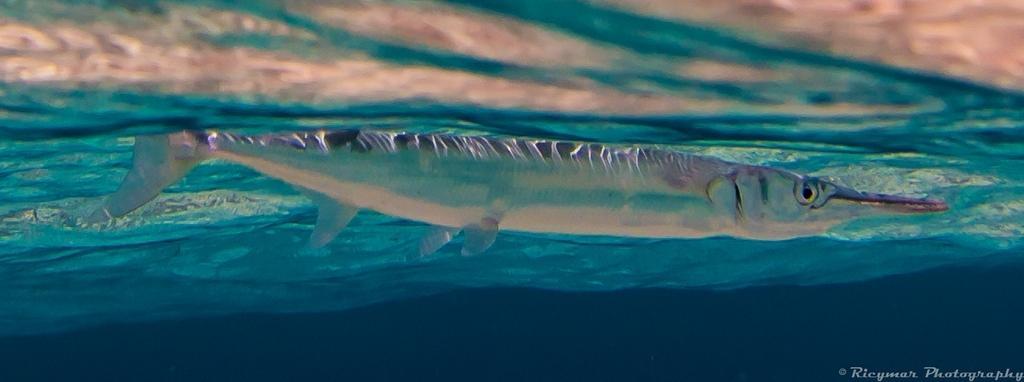Describe this image in one or two sentences. In this image there is a picture of a fish in the water. 